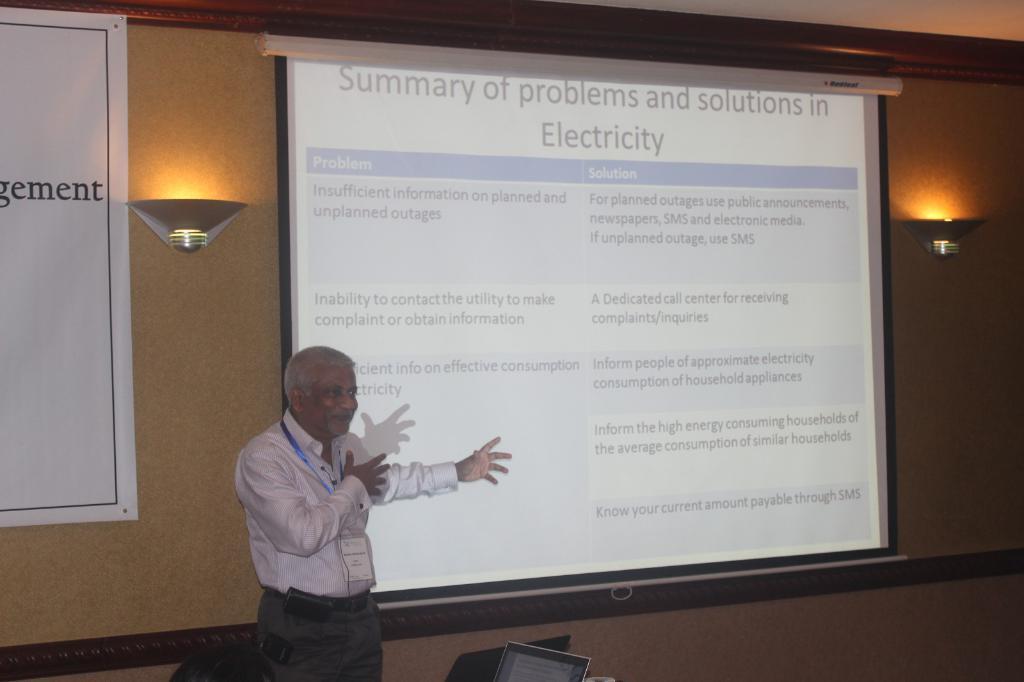Describe this image in one or two sentences. This is an inside view. Here I can see a man standing facing towards the right side and speaking. At the back of him there is a screen on which I can see the text. On the left side there is a banner attached to the wall. On both sides of the screen there are two lights. At the bottom there are two laptops. 